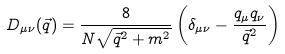<formula> <loc_0><loc_0><loc_500><loc_500>D _ { \mu \nu } ( \vec { q } ) = \frac { 8 } { N \sqrt { \vec { q } ^ { 2 } + m ^ { 2 } } } \left ( \delta _ { \mu \nu } - \frac { q _ { \mu } q _ { \nu } } { \vec { q } ^ { 2 } } \right )</formula> 